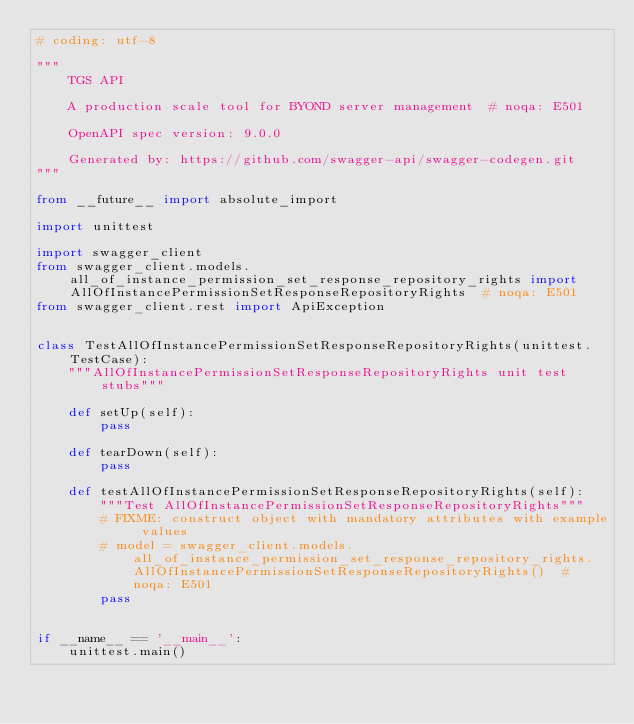Convert code to text. <code><loc_0><loc_0><loc_500><loc_500><_Python_># coding: utf-8

"""
    TGS API

    A production scale tool for BYOND server management  # noqa: E501

    OpenAPI spec version: 9.0.0
    
    Generated by: https://github.com/swagger-api/swagger-codegen.git
"""

from __future__ import absolute_import

import unittest

import swagger_client
from swagger_client.models.all_of_instance_permission_set_response_repository_rights import AllOfInstancePermissionSetResponseRepositoryRights  # noqa: E501
from swagger_client.rest import ApiException


class TestAllOfInstancePermissionSetResponseRepositoryRights(unittest.TestCase):
    """AllOfInstancePermissionSetResponseRepositoryRights unit test stubs"""

    def setUp(self):
        pass

    def tearDown(self):
        pass

    def testAllOfInstancePermissionSetResponseRepositoryRights(self):
        """Test AllOfInstancePermissionSetResponseRepositoryRights"""
        # FIXME: construct object with mandatory attributes with example values
        # model = swagger_client.models.all_of_instance_permission_set_response_repository_rights.AllOfInstancePermissionSetResponseRepositoryRights()  # noqa: E501
        pass


if __name__ == '__main__':
    unittest.main()
</code> 